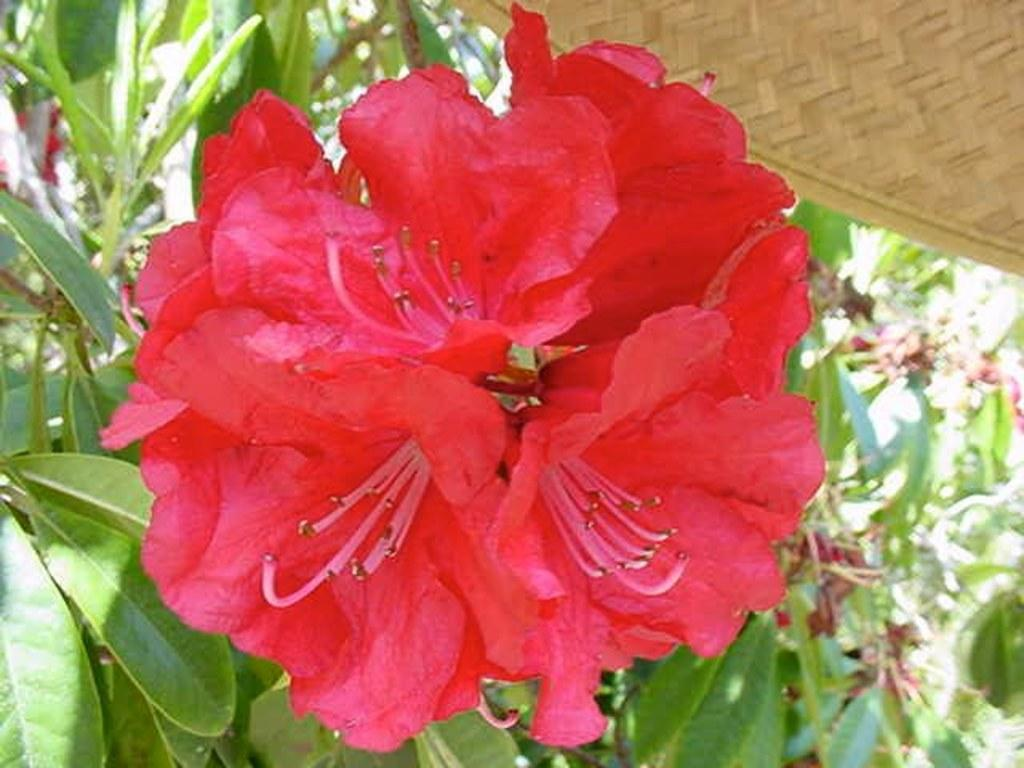What is the main subject of the picture? The main subject of the picture is a flower. Can you describe the flower in the picture? The flower is red. What can be seen in the background of the picture? There are plants in the background of the picture. What is located in the right top of the picture? There is a dried grass mat in the right top of the picture. What type of island can be seen in the background of the picture? There is no island present in the background of the picture; it features plants instead. Is there any indication of a birthday celebration in the picture? There is no indication of a birthday celebration in the picture; it only contains a red flower, plants, and a dried grass mat. 